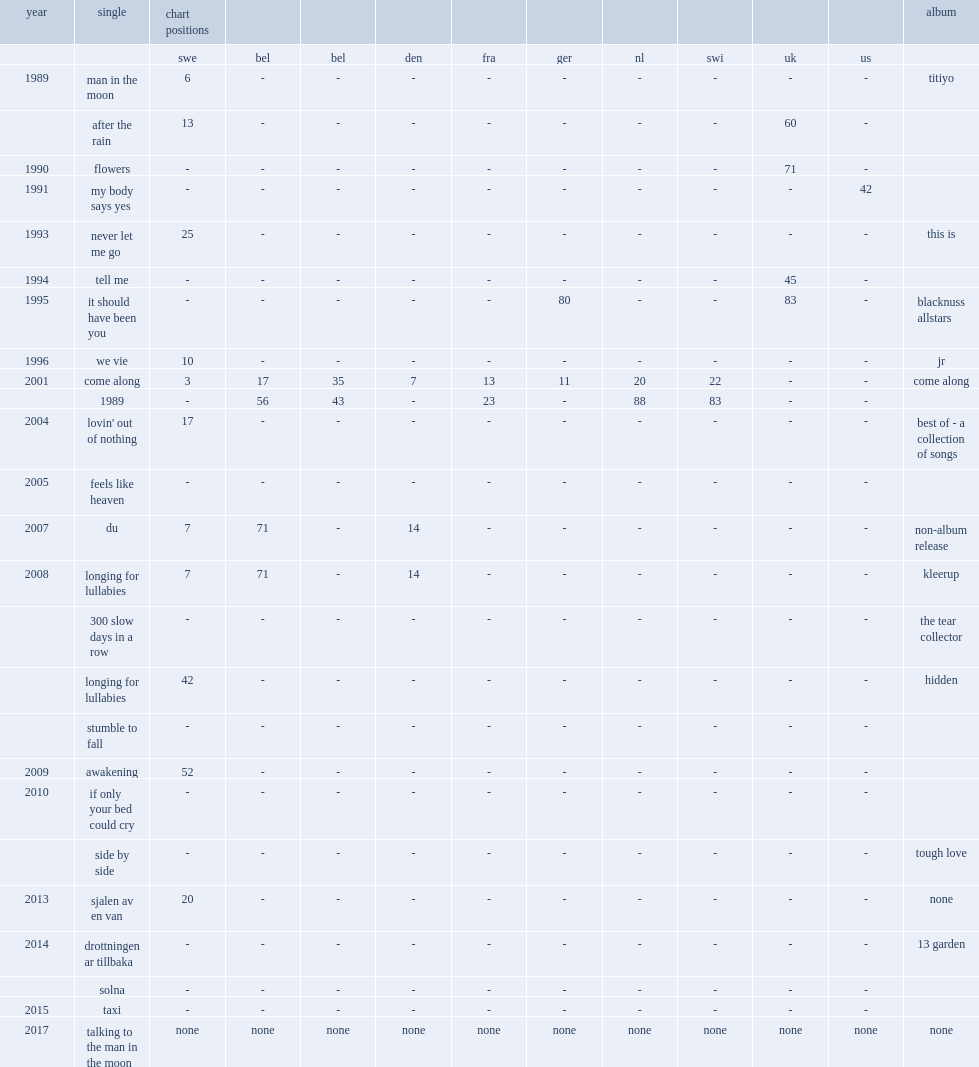When did the single"come along" release? 2001.0. 